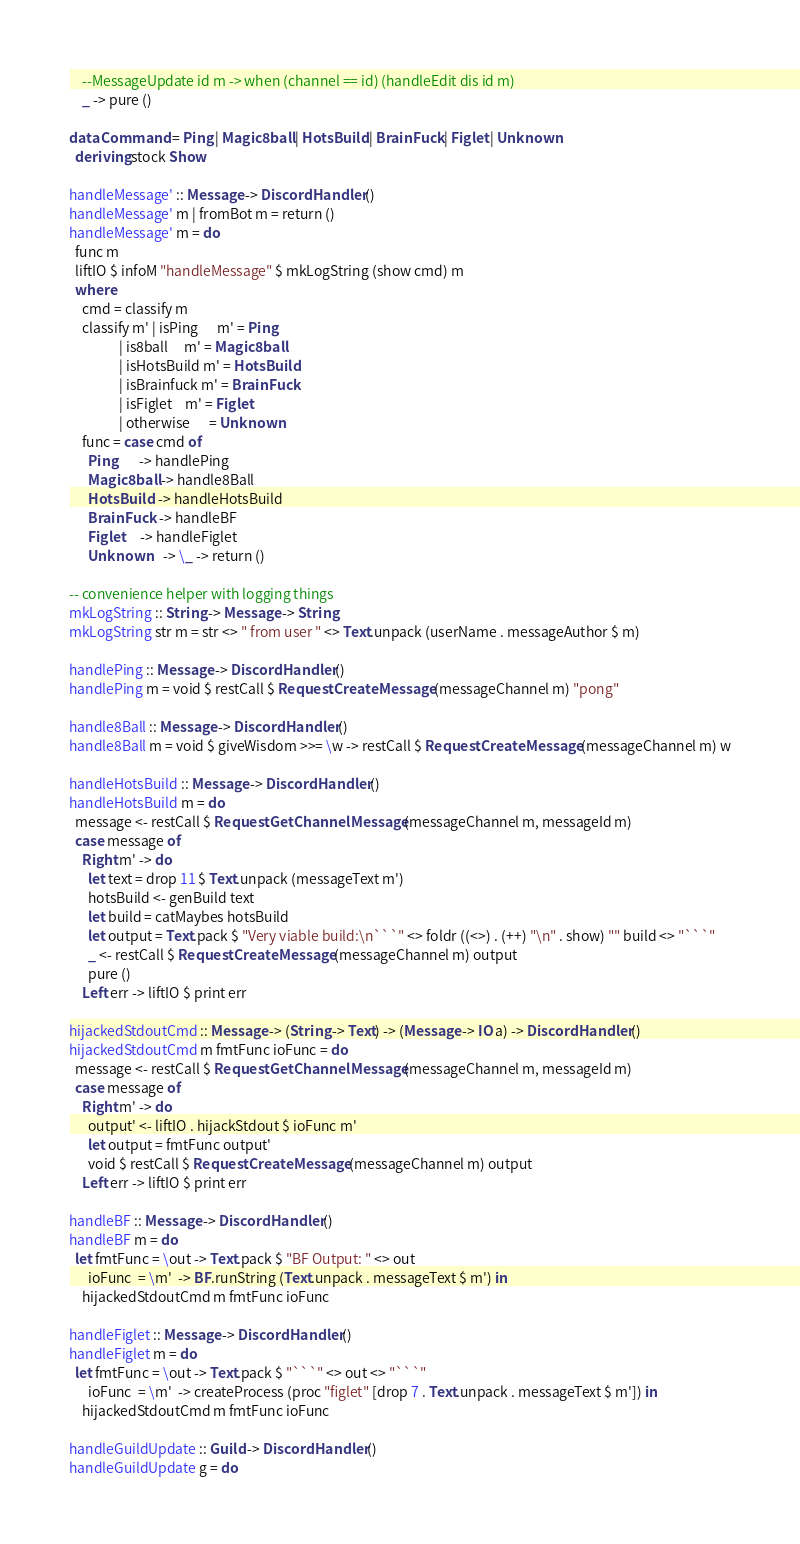Convert code to text. <code><loc_0><loc_0><loc_500><loc_500><_Haskell_>    --MessageUpdate id m -> when (channel == id) (handleEdit dis id m)
    _ -> pure ()

data Command = Ping | Magic8ball | HotsBuild | BrainFuck | Figlet | Unknown
  deriving stock Show

handleMessage' :: Message -> DiscordHandler ()
handleMessage' m | fromBot m = return ()
handleMessage' m = do
  func m 
  liftIO $ infoM "handleMessage" $ mkLogString (show cmd) m
  where 
    cmd = classify m
    classify m' | isPing      m' = Ping
                | is8ball     m' = Magic8ball
                | isHotsBuild m' = HotsBuild
                | isBrainfuck m' = BrainFuck
                | isFiglet    m' = Figlet
                | otherwise      = Unknown
    func = case cmd of
      Ping       -> handlePing
      Magic8ball -> handle8Ball
      HotsBuild  -> handleHotsBuild
      BrainFuck  -> handleBF
      Figlet     -> handleFiglet
      Unknown    -> \_ -> return () 

-- convenience helper with logging things
mkLogString :: String -> Message -> String
mkLogString str m = str <> " from user " <> Text.unpack (userName . messageAuthor $ m)

handlePing :: Message -> DiscordHandler ()
handlePing m = void $ restCall $ Request.CreateMessage (messageChannel m) "pong"

handle8Ball :: Message -> DiscordHandler ()
handle8Ball m = void $ giveWisdom >>= \w -> restCall $ Request.CreateMessage (messageChannel m) w

handleHotsBuild :: Message -> DiscordHandler ()
handleHotsBuild m = do
  message <- restCall $ Request.GetChannelMessage (messageChannel m, messageId m)
  case message of
    Right m' -> do
      let text = drop 11 $ Text.unpack (messageText m')
      hotsBuild <- genBuild text
      let build = catMaybes hotsBuild
      let output = Text.pack $ "Very viable build:\n```" <> foldr ((<>) . (++) "\n" . show) "" build <> "```"
      _ <- restCall $ Request.CreateMessage (messageChannel m) output
      pure ()
    Left err -> liftIO $ print err

hijackedStdoutCmd :: Message -> (String -> Text) -> (Message -> IO a) -> DiscordHandler ()
hijackedStdoutCmd m fmtFunc ioFunc = do
  message <- restCall $ Request.GetChannelMessage (messageChannel m, messageId m)
  case message of
    Right m' -> do
      output' <- liftIO . hijackStdout $ ioFunc m'
      let output = fmtFunc output'
      void $ restCall $ Request.CreateMessage (messageChannel m) output
    Left err -> liftIO $ print err

handleBF :: Message -> DiscordHandler ()
handleBF m = do
  let fmtFunc = \out -> Text.pack $ "BF Output: " <> out 
      ioFunc  = \m'  -> BF.runString (Text.unpack . messageText $ m') in
    hijackedStdoutCmd m fmtFunc ioFunc

handleFiglet :: Message -> DiscordHandler ()
handleFiglet m = do
  let fmtFunc = \out -> Text.pack $ "```" <> out <> "```"
      ioFunc  = \m'  -> createProcess (proc "figlet" [drop 7 . Text.unpack . messageText $ m']) in
    hijackedStdoutCmd m fmtFunc ioFunc

handleGuildUpdate :: Guild -> DiscordHandler ()
handleGuildUpdate g = do</code> 